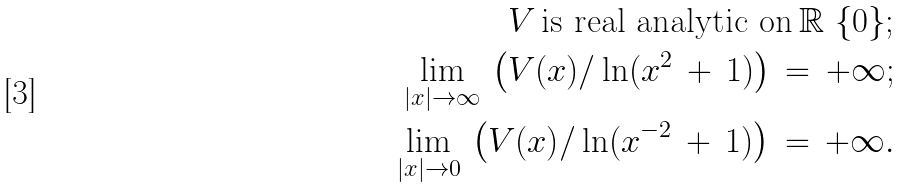Convert formula to latex. <formula><loc_0><loc_0><loc_500><loc_500>V \, \text {is real analytic on} \, \mathbb { R } \ \{ 0 \} ; \\ \lim _ { | x | \to \infty } \, \left ( V ( x ) / \ln ( x ^ { 2 } \, + \, 1 ) \right ) \, = \, + \infty ; \\ \lim _ { | x | \to 0 } \, \left ( V ( x ) / \ln ( x ^ { - 2 } \, + \, 1 ) \right ) \, = \, + \infty .</formula> 